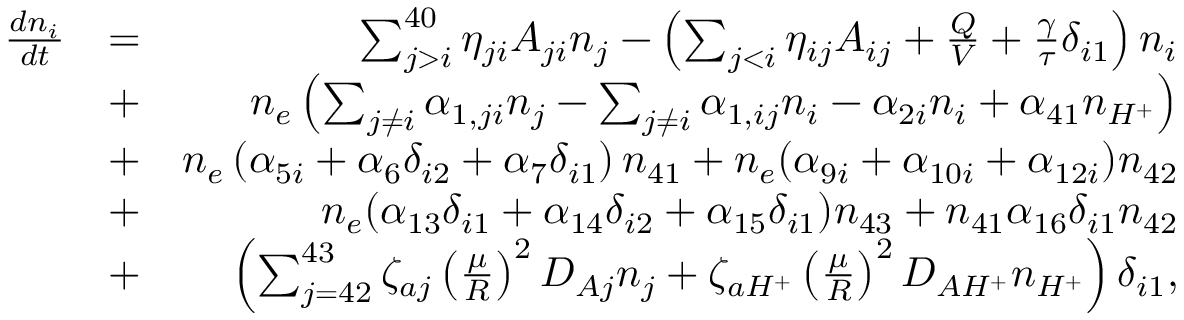<formula> <loc_0><loc_0><loc_500><loc_500>\begin{array} { r l r } { \frac { d n _ { i } } { d t } } & { = } & { \sum _ { j > i } ^ { 4 0 } \eta _ { j i } A _ { j i } n _ { j } - \left ( \sum _ { j < i } \eta _ { i j } A _ { i j } + \frac { Q } { V } + \frac { \gamma } { \tau } \delta _ { i 1 } \right ) n _ { i } } \\ & { + } & { n _ { e } \left ( \sum _ { j \neq i } \alpha _ { 1 , j i } n _ { j } - \sum _ { j \neq i } \alpha _ { 1 , i j } n _ { i } - \alpha _ { 2 i } n _ { i } + \alpha _ { 4 1 } n _ { H ^ { + } } \right ) } \\ & { + } & { n _ { e } \left ( \alpha _ { 5 i } + \alpha _ { 6 } \delta _ { i 2 } + \alpha _ { 7 } \delta _ { i 1 } \right ) n _ { 4 1 } + n _ { e } ( \alpha _ { 9 i } + \alpha _ { 1 0 i } + \alpha _ { 1 2 i } ) n _ { 4 2 } } \\ & { + } & { n _ { e } ( \alpha _ { 1 3 } \delta _ { i 1 } + \alpha _ { 1 4 } \delta _ { i 2 } + \alpha _ { 1 5 } \delta _ { i 1 } ) n _ { 4 3 } + n _ { 4 1 } \alpha _ { 1 6 } \delta _ { i 1 } n _ { 4 2 } } \\ & { + } & { \left ( \sum _ { j = 4 2 } ^ { 4 3 } \zeta _ { a j } \left ( \frac { \mu } { R } \right ) ^ { 2 } D _ { A j } n _ { j } + \zeta _ { a H ^ { + } } \left ( \frac { \mu } { R } \right ) ^ { 2 } D _ { A H ^ { + } } n _ { H ^ { + } } \right ) \delta _ { i 1 } , } \end{array}</formula> 